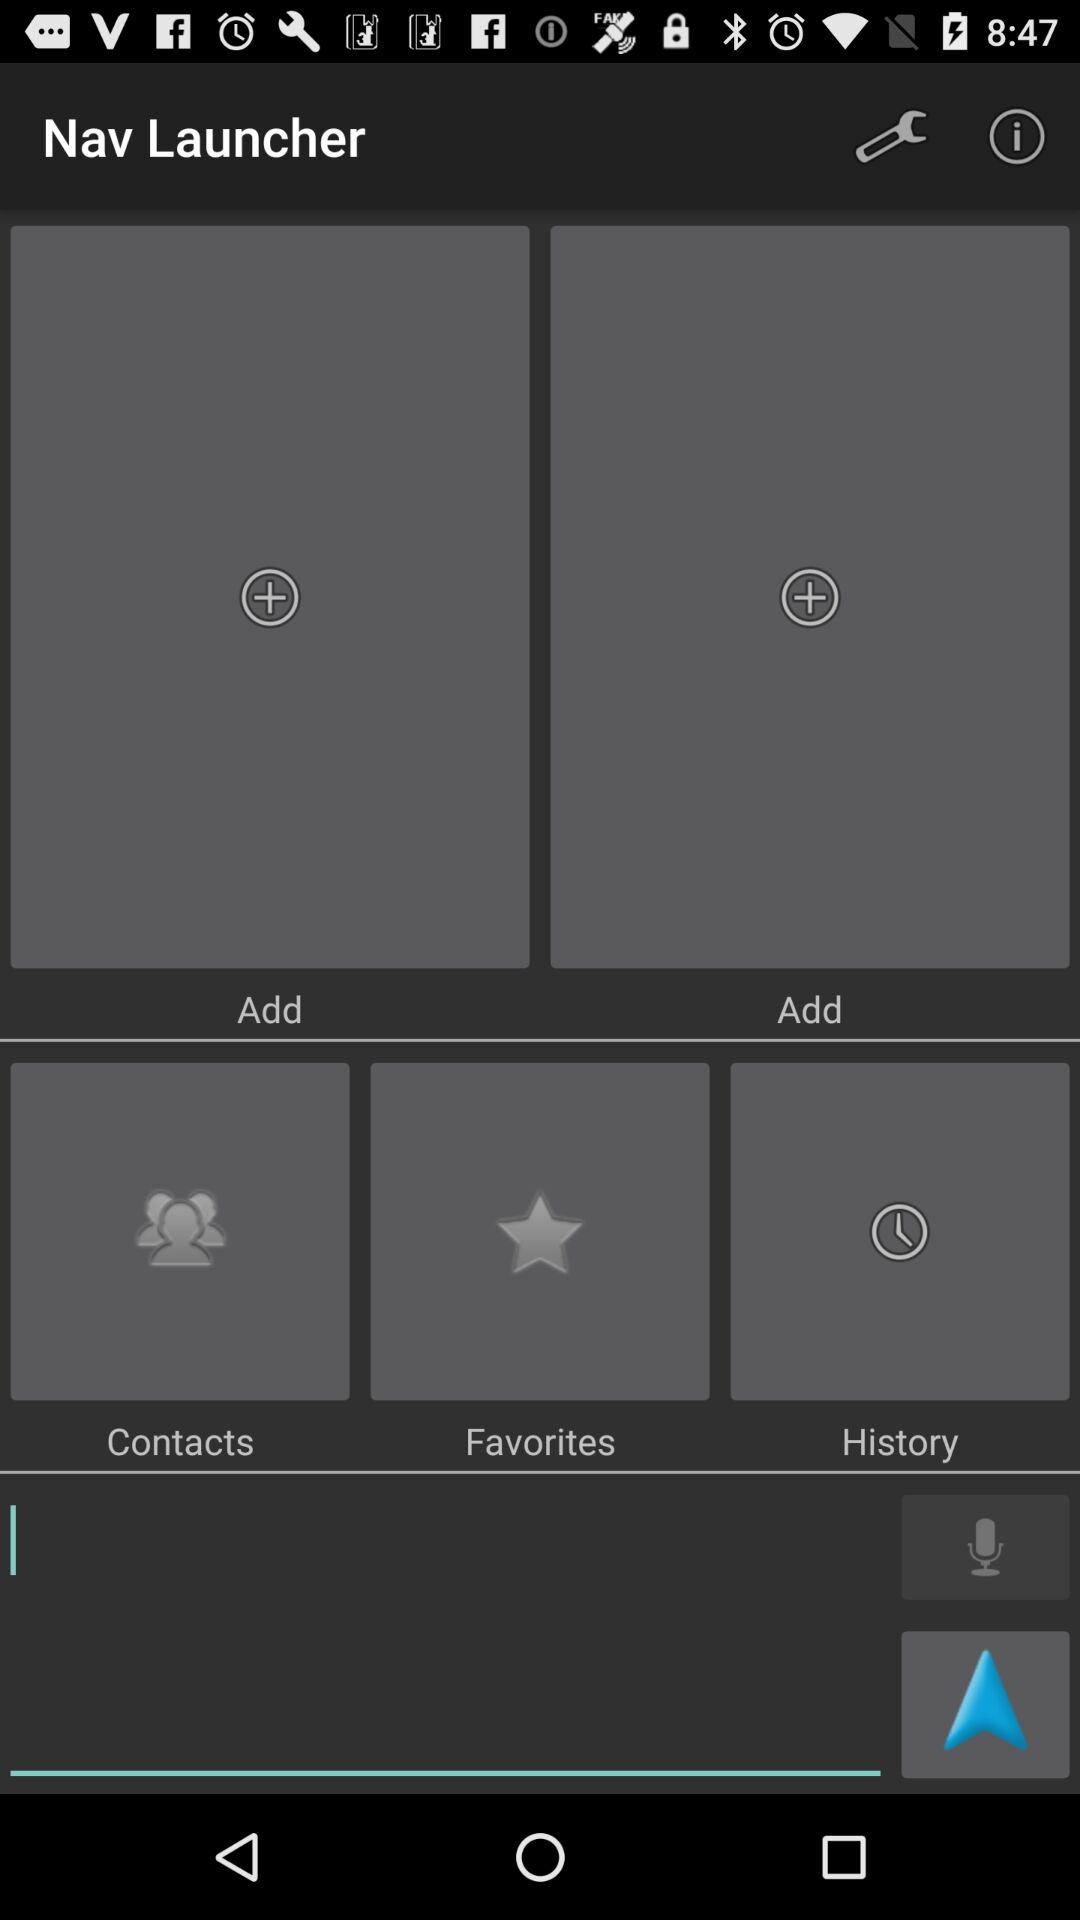How many items have the text 'Add'?
Answer the question using a single word or phrase. 2 